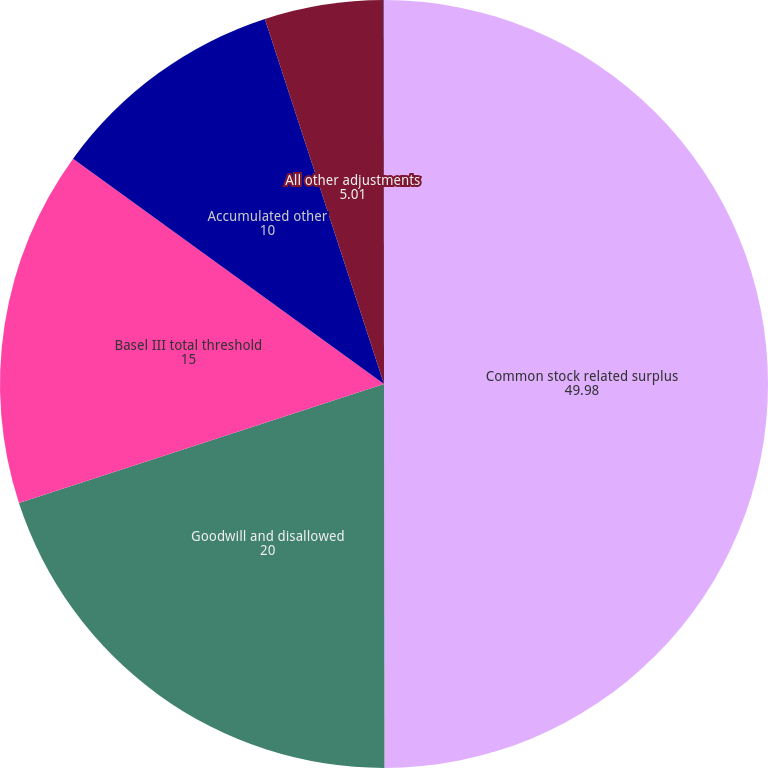Convert chart to OTSL. <chart><loc_0><loc_0><loc_500><loc_500><pie_chart><fcel>Common stock related surplus<fcel>Goodwill and disallowed<fcel>Basel III total threshold<fcel>Accumulated other<fcel>All other adjustments<fcel>Basel III Common equity Tier 1<nl><fcel>49.98%<fcel>20.0%<fcel>15.0%<fcel>10.0%<fcel>5.01%<fcel>0.01%<nl></chart> 